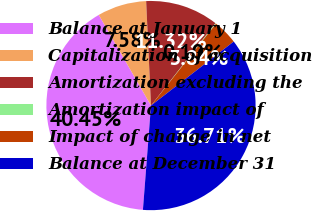<chart> <loc_0><loc_0><loc_500><loc_500><pie_chart><fcel>Balance at January 1<fcel>Capitalization of acquisition<fcel>Amortization excluding the<fcel>Amortization impact of<fcel>Impact of change in net<fcel>Balance at December 31<nl><fcel>40.46%<fcel>7.58%<fcel>11.32%<fcel>0.1%<fcel>3.84%<fcel>36.72%<nl></chart> 